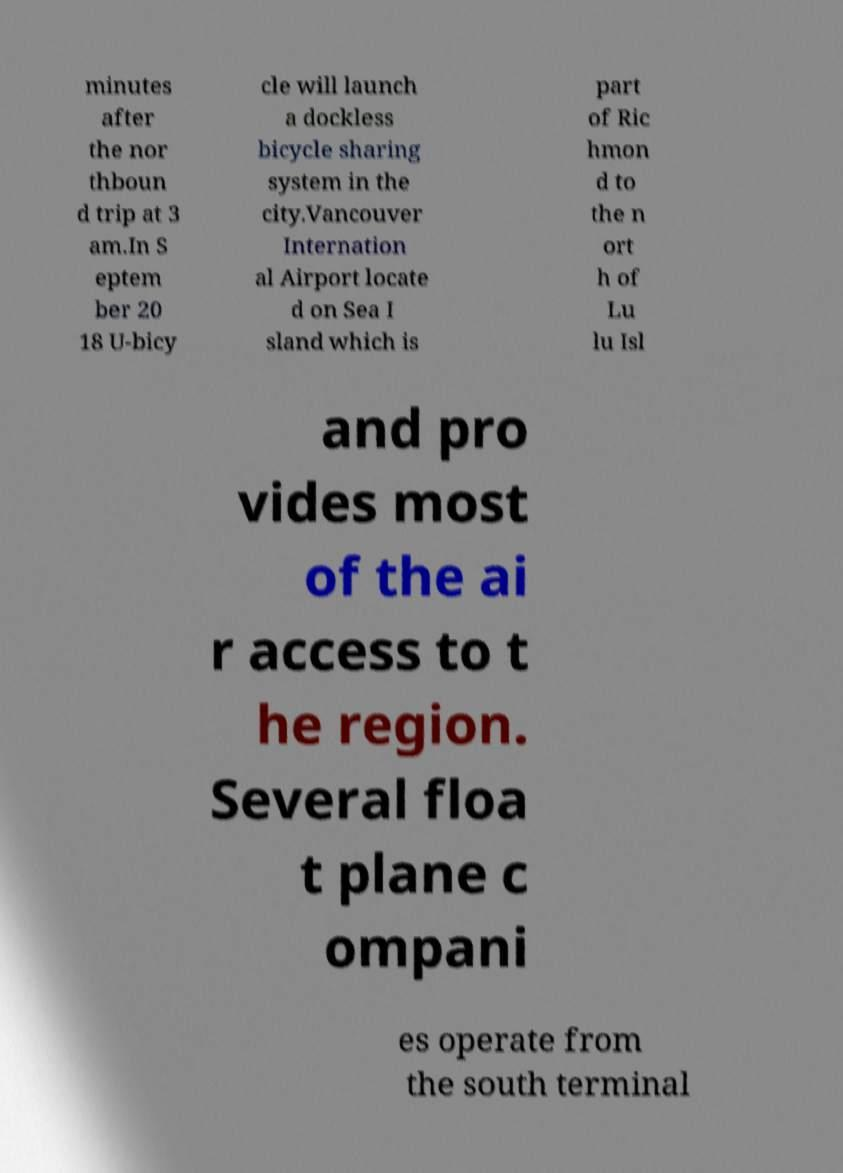Can you read and provide the text displayed in the image?This photo seems to have some interesting text. Can you extract and type it out for me? minutes after the nor thboun d trip at 3 am.In S eptem ber 20 18 U-bicy cle will launch a dockless bicycle sharing system in the city.Vancouver Internation al Airport locate d on Sea I sland which is part of Ric hmon d to the n ort h of Lu lu Isl and pro vides most of the ai r access to t he region. Several floa t plane c ompani es operate from the south terminal 